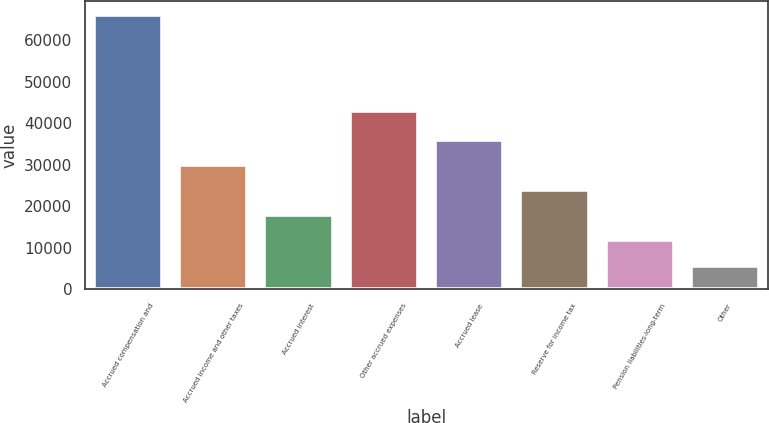Convert chart. <chart><loc_0><loc_0><loc_500><loc_500><bar_chart><fcel>Accrued compensation and<fcel>Accrued income and other taxes<fcel>Accrued interest<fcel>Other accrued expenses<fcel>Accrued lease<fcel>Reserve for income tax<fcel>Pension liabilities-long-term<fcel>Other<nl><fcel>66052<fcel>29872<fcel>17812<fcel>42992<fcel>35902<fcel>23842<fcel>11782<fcel>5752<nl></chart> 